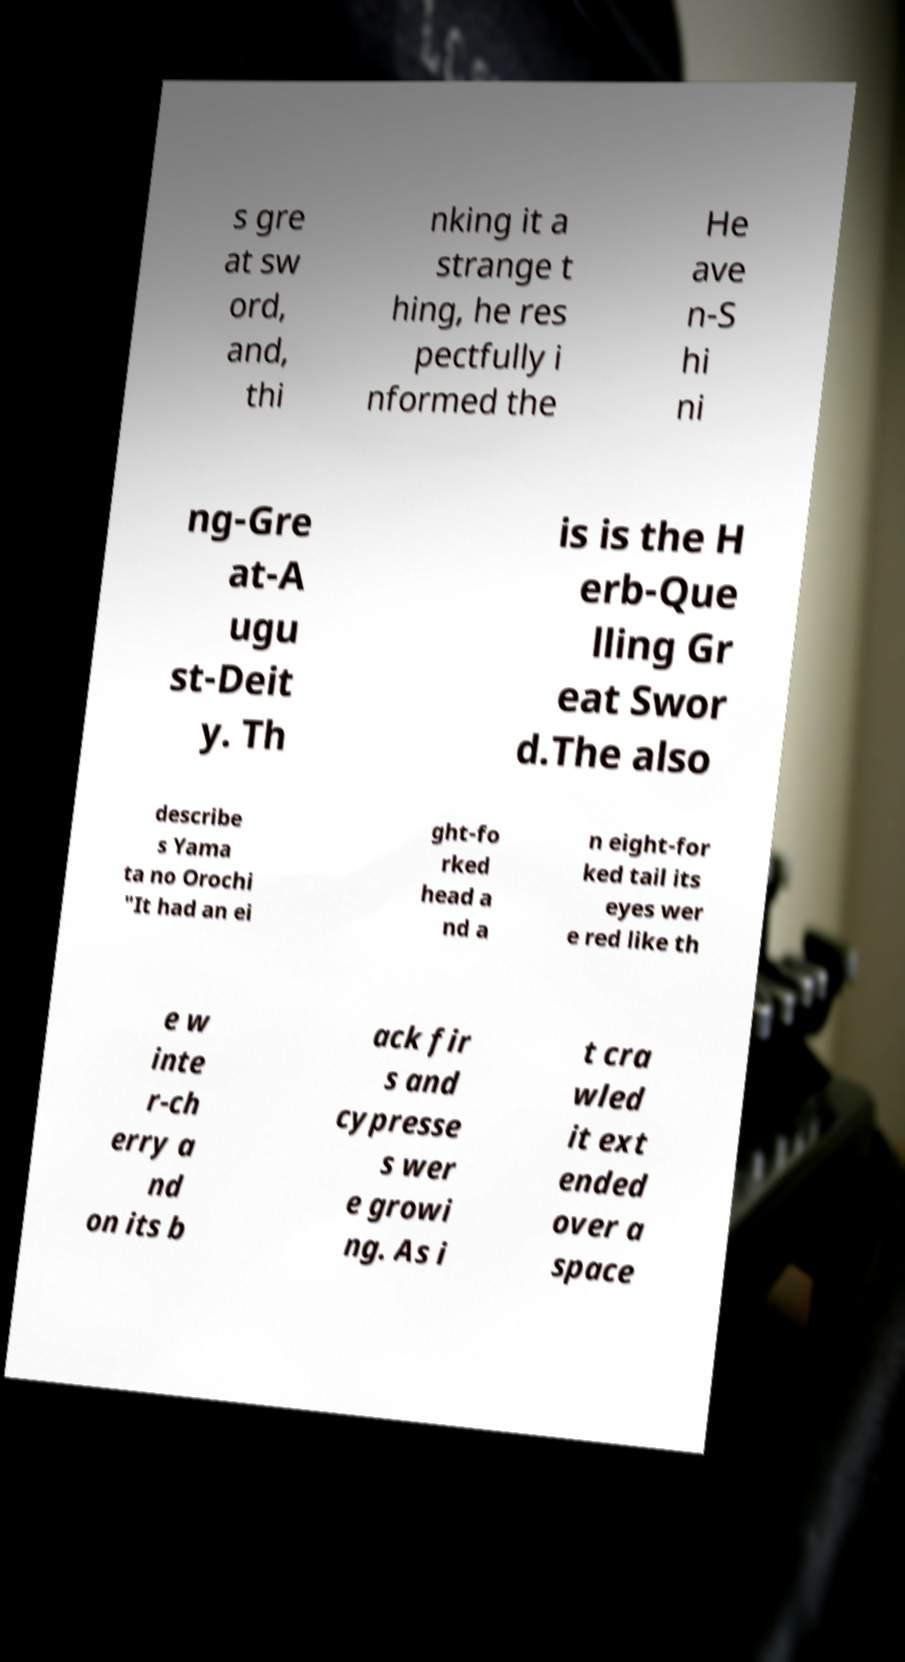Could you assist in decoding the text presented in this image and type it out clearly? s gre at sw ord, and, thi nking it a strange t hing, he res pectfully i nformed the He ave n-S hi ni ng-Gre at-A ugu st-Deit y. Th is is the H erb-Que lling Gr eat Swor d.The also describe s Yama ta no Orochi "It had an ei ght-fo rked head a nd a n eight-for ked tail its eyes wer e red like th e w inte r-ch erry a nd on its b ack fir s and cypresse s wer e growi ng. As i t cra wled it ext ended over a space 